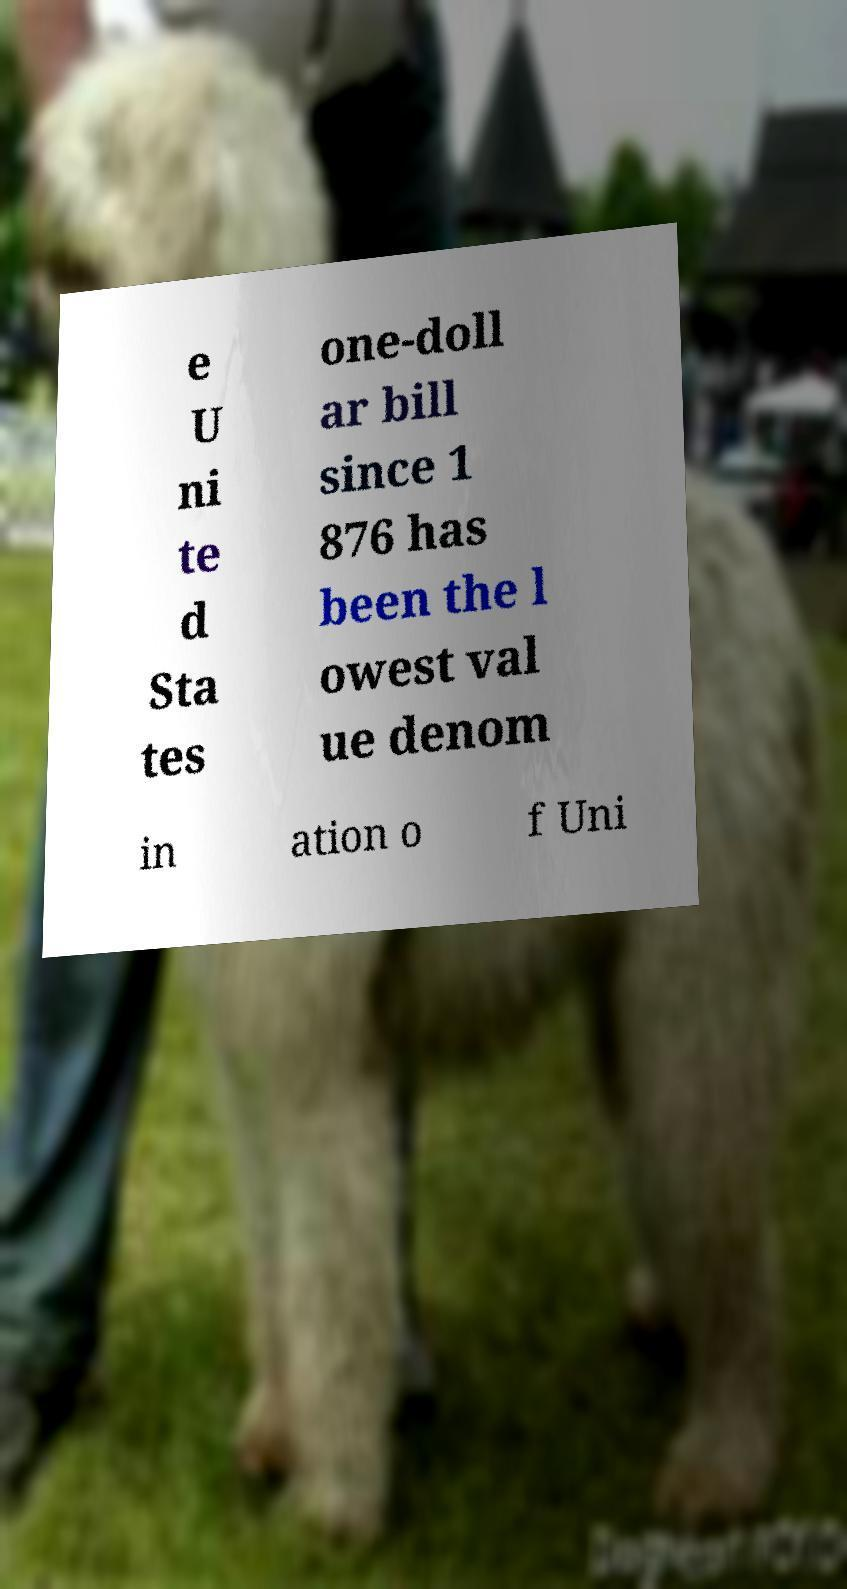Please identify and transcribe the text found in this image. e U ni te d Sta tes one-doll ar bill since 1 876 has been the l owest val ue denom in ation o f Uni 